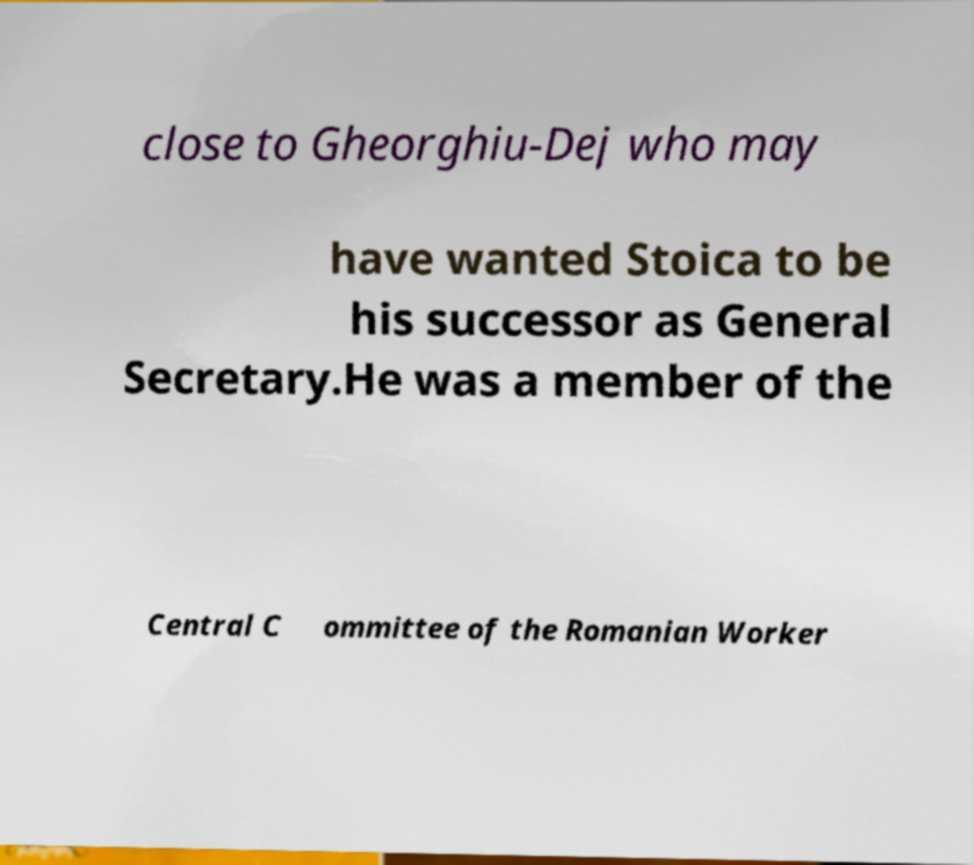There's text embedded in this image that I need extracted. Can you transcribe it verbatim? close to Gheorghiu-Dej who may have wanted Stoica to be his successor as General Secretary.He was a member of the Central C ommittee of the Romanian Worker 